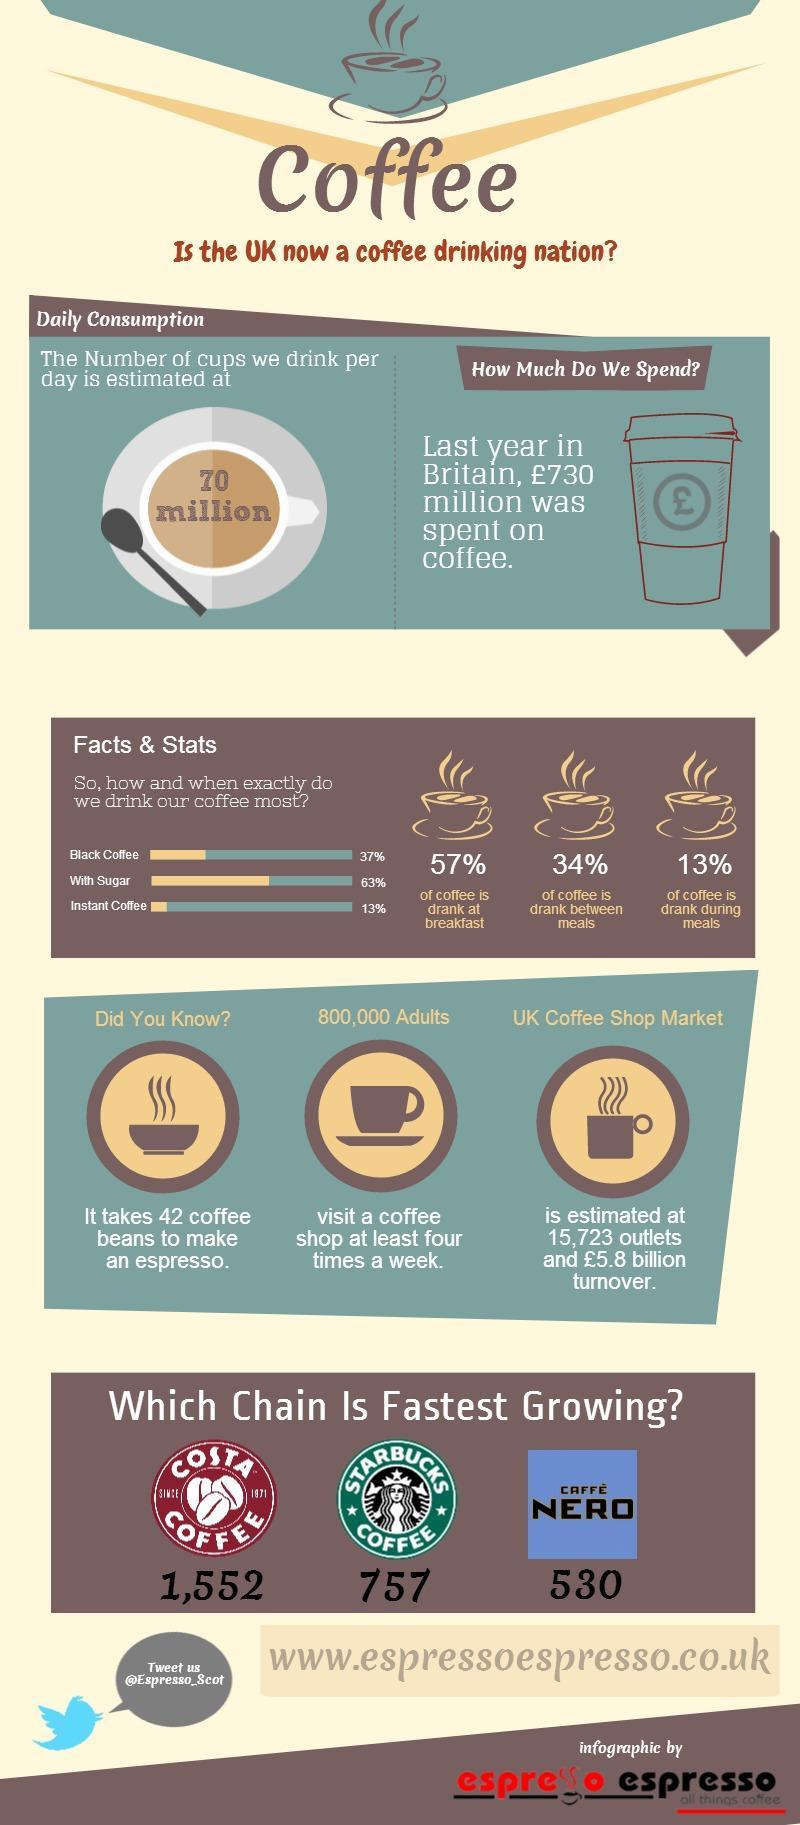When was the coffee drunk the most?
Answer the question with a short phrase. At Breakfast Which chain has the second fastest growth? Starbucks What is the overall turnover for the UK Coffee shop market? £5.8 billion How is coffee consumed the most? Black coffee How many more starbucks are there compared to caffe Nero? 227 How is coffee consumed the least? Instant coffee 